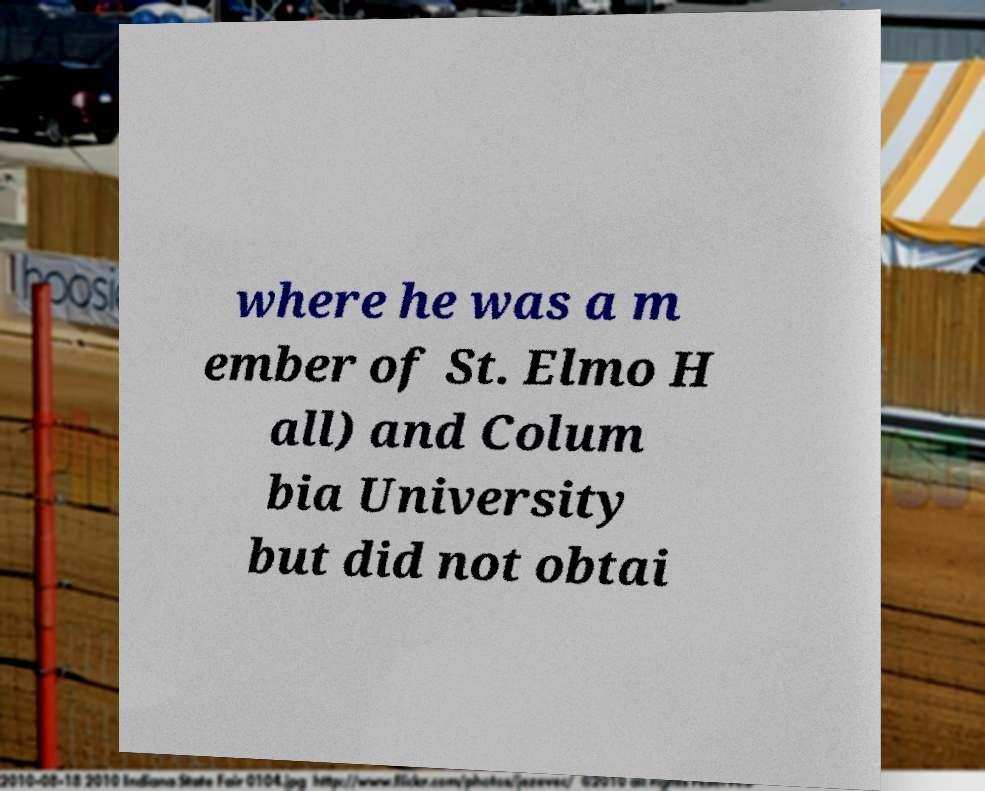Can you accurately transcribe the text from the provided image for me? where he was a m ember of St. Elmo H all) and Colum bia University but did not obtai 